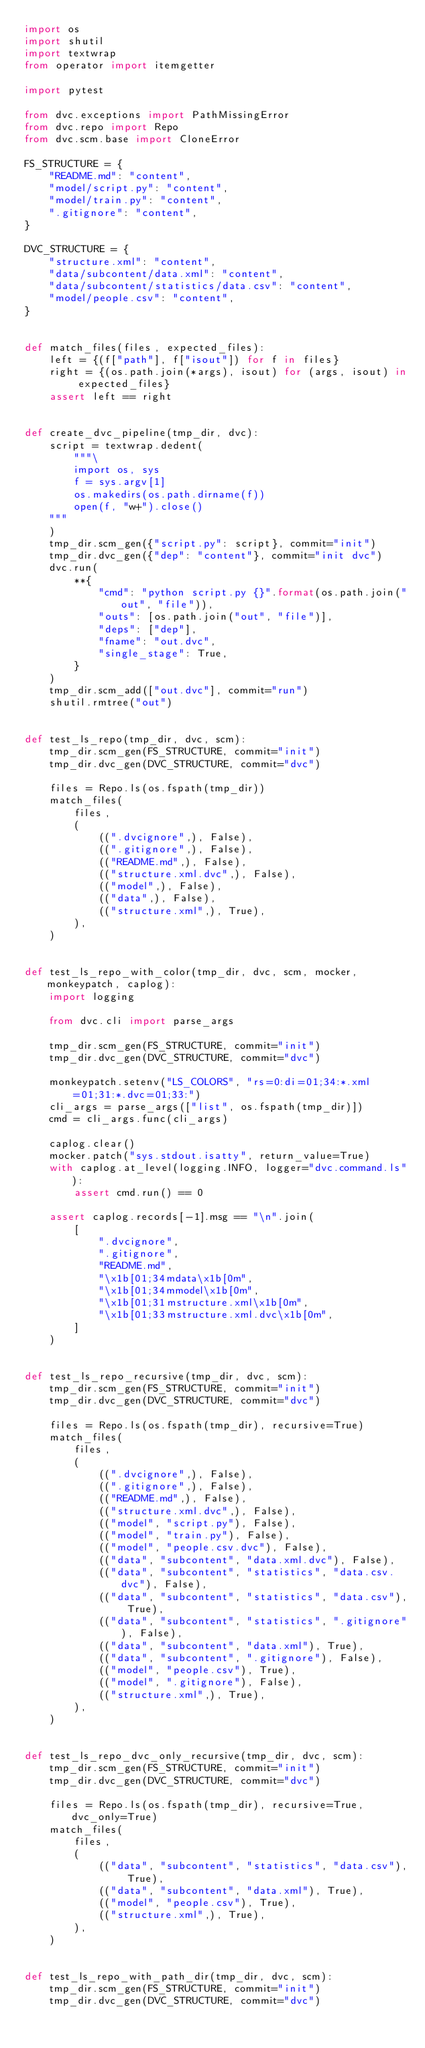<code> <loc_0><loc_0><loc_500><loc_500><_Python_>import os
import shutil
import textwrap
from operator import itemgetter

import pytest

from dvc.exceptions import PathMissingError
from dvc.repo import Repo
from dvc.scm.base import CloneError

FS_STRUCTURE = {
    "README.md": "content",
    "model/script.py": "content",
    "model/train.py": "content",
    ".gitignore": "content",
}

DVC_STRUCTURE = {
    "structure.xml": "content",
    "data/subcontent/data.xml": "content",
    "data/subcontent/statistics/data.csv": "content",
    "model/people.csv": "content",
}


def match_files(files, expected_files):
    left = {(f["path"], f["isout"]) for f in files}
    right = {(os.path.join(*args), isout) for (args, isout) in expected_files}
    assert left == right


def create_dvc_pipeline(tmp_dir, dvc):
    script = textwrap.dedent(
        """\
        import os, sys
        f = sys.argv[1]
        os.makedirs(os.path.dirname(f))
        open(f, "w+").close()
    """
    )
    tmp_dir.scm_gen({"script.py": script}, commit="init")
    tmp_dir.dvc_gen({"dep": "content"}, commit="init dvc")
    dvc.run(
        **{
            "cmd": "python script.py {}".format(os.path.join("out", "file")),
            "outs": [os.path.join("out", "file")],
            "deps": ["dep"],
            "fname": "out.dvc",
            "single_stage": True,
        }
    )
    tmp_dir.scm_add(["out.dvc"], commit="run")
    shutil.rmtree("out")


def test_ls_repo(tmp_dir, dvc, scm):
    tmp_dir.scm_gen(FS_STRUCTURE, commit="init")
    tmp_dir.dvc_gen(DVC_STRUCTURE, commit="dvc")

    files = Repo.ls(os.fspath(tmp_dir))
    match_files(
        files,
        (
            ((".dvcignore",), False),
            ((".gitignore",), False),
            (("README.md",), False),
            (("structure.xml.dvc",), False),
            (("model",), False),
            (("data",), False),
            (("structure.xml",), True),
        ),
    )


def test_ls_repo_with_color(tmp_dir, dvc, scm, mocker, monkeypatch, caplog):
    import logging

    from dvc.cli import parse_args

    tmp_dir.scm_gen(FS_STRUCTURE, commit="init")
    tmp_dir.dvc_gen(DVC_STRUCTURE, commit="dvc")

    monkeypatch.setenv("LS_COLORS", "rs=0:di=01;34:*.xml=01;31:*.dvc=01;33:")
    cli_args = parse_args(["list", os.fspath(tmp_dir)])
    cmd = cli_args.func(cli_args)

    caplog.clear()
    mocker.patch("sys.stdout.isatty", return_value=True)
    with caplog.at_level(logging.INFO, logger="dvc.command.ls"):
        assert cmd.run() == 0

    assert caplog.records[-1].msg == "\n".join(
        [
            ".dvcignore",
            ".gitignore",
            "README.md",
            "\x1b[01;34mdata\x1b[0m",
            "\x1b[01;34mmodel\x1b[0m",
            "\x1b[01;31mstructure.xml\x1b[0m",
            "\x1b[01;33mstructure.xml.dvc\x1b[0m",
        ]
    )


def test_ls_repo_recursive(tmp_dir, dvc, scm):
    tmp_dir.scm_gen(FS_STRUCTURE, commit="init")
    tmp_dir.dvc_gen(DVC_STRUCTURE, commit="dvc")

    files = Repo.ls(os.fspath(tmp_dir), recursive=True)
    match_files(
        files,
        (
            ((".dvcignore",), False),
            ((".gitignore",), False),
            (("README.md",), False),
            (("structure.xml.dvc",), False),
            (("model", "script.py"), False),
            (("model", "train.py"), False),
            (("model", "people.csv.dvc"), False),
            (("data", "subcontent", "data.xml.dvc"), False),
            (("data", "subcontent", "statistics", "data.csv.dvc"), False),
            (("data", "subcontent", "statistics", "data.csv"), True),
            (("data", "subcontent", "statistics", ".gitignore"), False),
            (("data", "subcontent", "data.xml"), True),
            (("data", "subcontent", ".gitignore"), False),
            (("model", "people.csv"), True),
            (("model", ".gitignore"), False),
            (("structure.xml",), True),
        ),
    )


def test_ls_repo_dvc_only_recursive(tmp_dir, dvc, scm):
    tmp_dir.scm_gen(FS_STRUCTURE, commit="init")
    tmp_dir.dvc_gen(DVC_STRUCTURE, commit="dvc")

    files = Repo.ls(os.fspath(tmp_dir), recursive=True, dvc_only=True)
    match_files(
        files,
        (
            (("data", "subcontent", "statistics", "data.csv"), True),
            (("data", "subcontent", "data.xml"), True),
            (("model", "people.csv"), True),
            (("structure.xml",), True),
        ),
    )


def test_ls_repo_with_path_dir(tmp_dir, dvc, scm):
    tmp_dir.scm_gen(FS_STRUCTURE, commit="init")
    tmp_dir.dvc_gen(DVC_STRUCTURE, commit="dvc")
</code> 